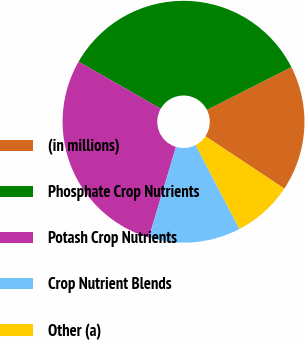Convert chart to OTSL. <chart><loc_0><loc_0><loc_500><loc_500><pie_chart><fcel>(in millions)<fcel>Phosphate Crop Nutrients<fcel>Potash Crop Nutrients<fcel>Crop Nutrient Blends<fcel>Other (a)<nl><fcel>16.79%<fcel>34.25%<fcel>28.65%<fcel>12.28%<fcel>8.02%<nl></chart> 